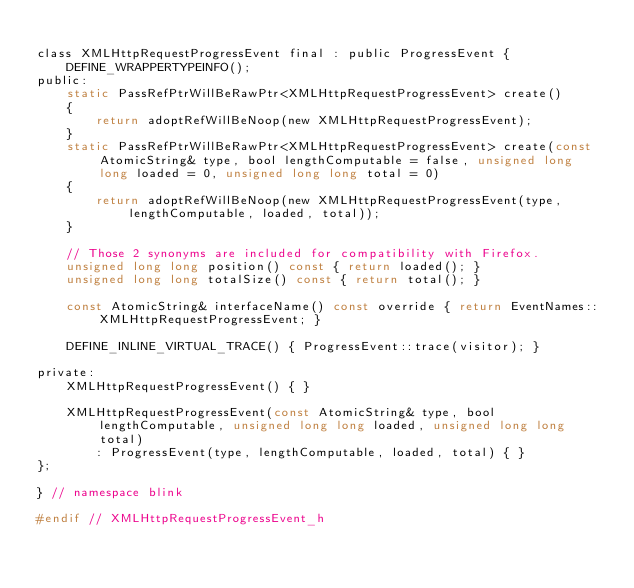<code> <loc_0><loc_0><loc_500><loc_500><_C_>
class XMLHttpRequestProgressEvent final : public ProgressEvent {
    DEFINE_WRAPPERTYPEINFO();
public:
    static PassRefPtrWillBeRawPtr<XMLHttpRequestProgressEvent> create()
    {
        return adoptRefWillBeNoop(new XMLHttpRequestProgressEvent);
    }
    static PassRefPtrWillBeRawPtr<XMLHttpRequestProgressEvent> create(const AtomicString& type, bool lengthComputable = false, unsigned long long loaded = 0, unsigned long long total = 0)
    {
        return adoptRefWillBeNoop(new XMLHttpRequestProgressEvent(type, lengthComputable, loaded, total));
    }

    // Those 2 synonyms are included for compatibility with Firefox.
    unsigned long long position() const { return loaded(); }
    unsigned long long totalSize() const { return total(); }

    const AtomicString& interfaceName() const override { return EventNames::XMLHttpRequestProgressEvent; }

    DEFINE_INLINE_VIRTUAL_TRACE() { ProgressEvent::trace(visitor); }

private:
    XMLHttpRequestProgressEvent() { }

    XMLHttpRequestProgressEvent(const AtomicString& type, bool lengthComputable, unsigned long long loaded, unsigned long long total)
        : ProgressEvent(type, lengthComputable, loaded, total) { }
};

} // namespace blink

#endif // XMLHttpRequestProgressEvent_h
</code> 